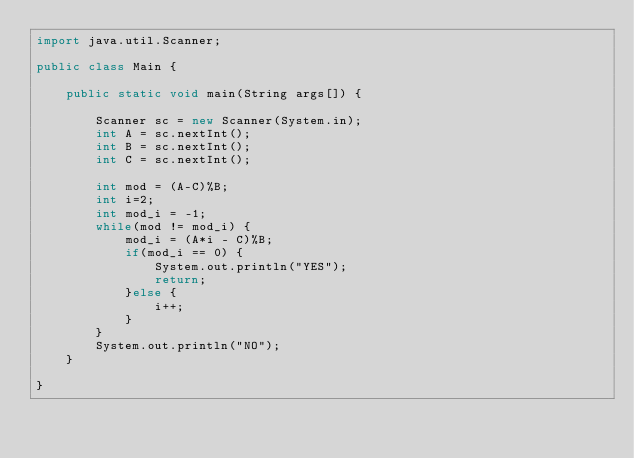<code> <loc_0><loc_0><loc_500><loc_500><_Java_>import java.util.Scanner;

public class Main {

	public static void main(String args[]) {

		Scanner sc = new Scanner(System.in);
		int A = sc.nextInt();
		int B = sc.nextInt();
		int C = sc.nextInt();

		int mod = (A-C)%B;
		int i=2;
		int mod_i = -1;
		while(mod != mod_i) {
			mod_i = (A*i - C)%B;
			if(mod_i == 0) {
				System.out.println("YES");
				return;
			}else {
				i++;
			}
		}
		System.out.println("NO");
	}

}
</code> 